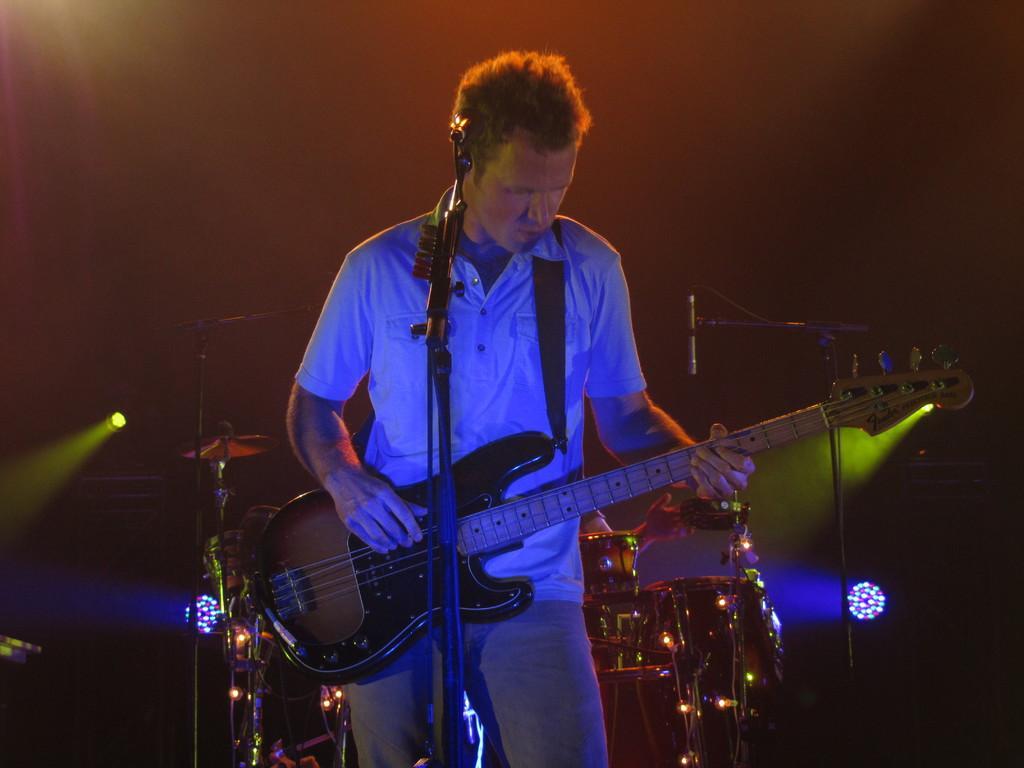Can you describe this image briefly? In this image i I can see a man is playing a guitar in front of a microphone. 